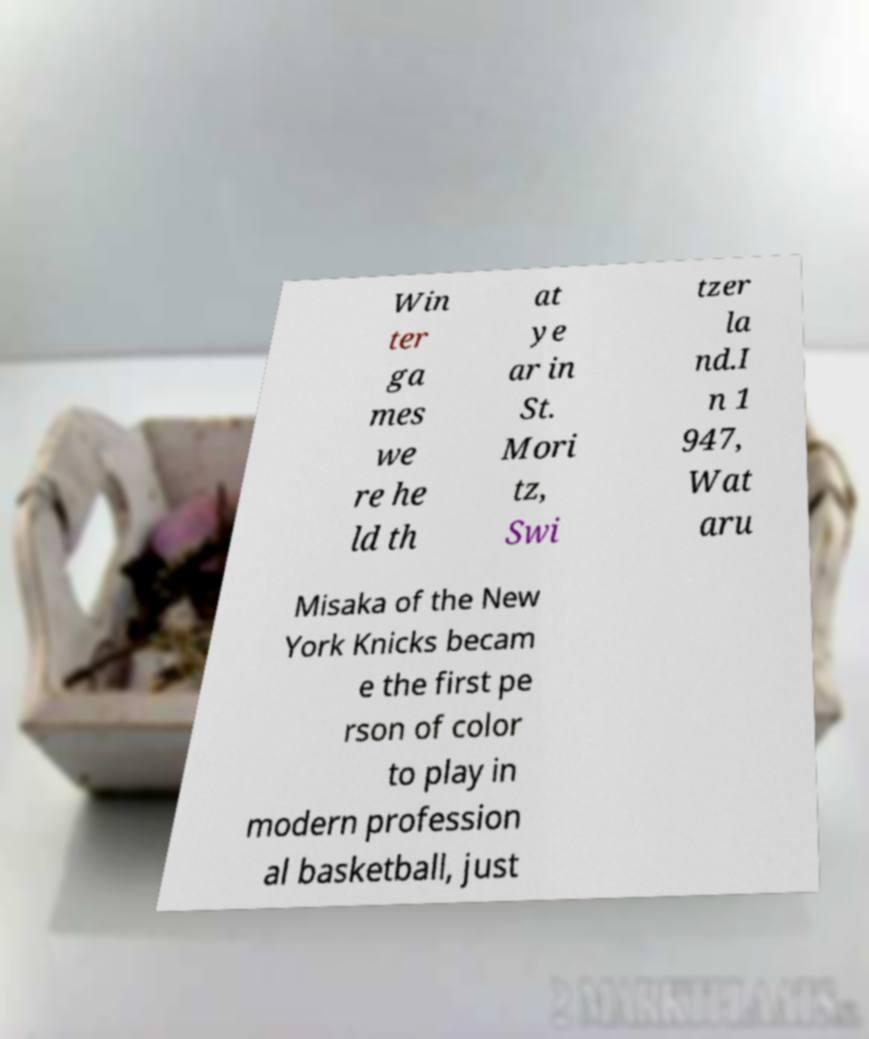Could you extract and type out the text from this image? Win ter ga mes we re he ld th at ye ar in St. Mori tz, Swi tzer la nd.I n 1 947, Wat aru Misaka of the New York Knicks becam e the first pe rson of color to play in modern profession al basketball, just 